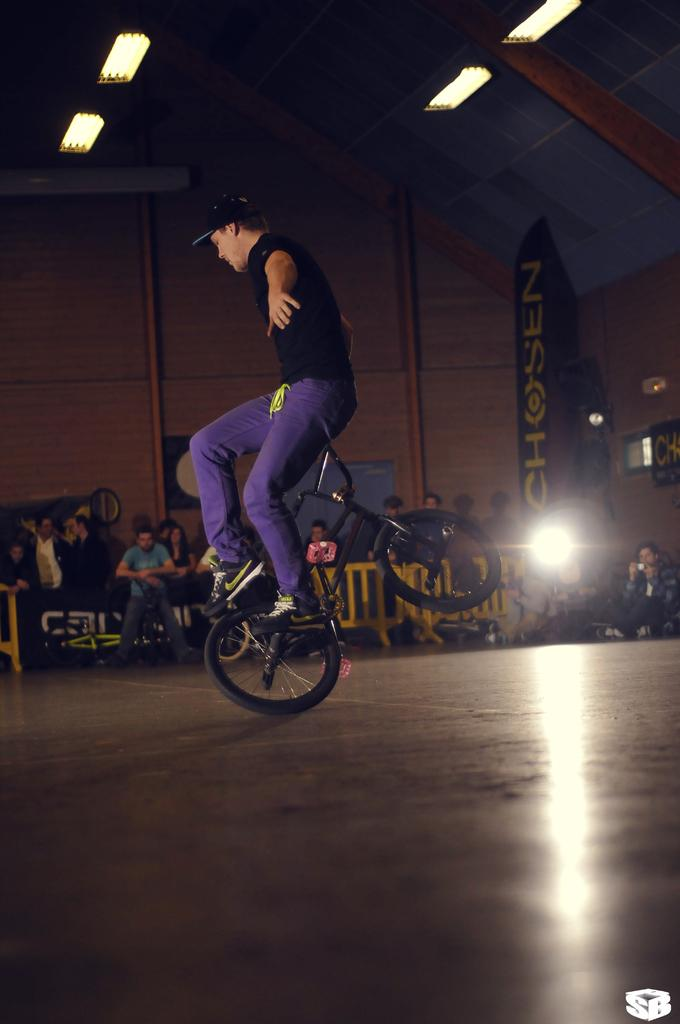How many people are in the image? There are people in the image, but the exact number is not specified. What can be seen in the image besides people? There are lights, railing, banners, a floor, and a bicycle in the image. What is the person sitting on the bicycle handle doing? One person is sitting on the bicycle handle, but their specific action is not described. What type of surface is the floor made of? The type of surface the floor is made of is not specified in the facts. Can you tell me how many ministers are present in the image? There is no mention of ministers in the image, so it is not possible to determine their presence or number. What type of park is visible in the image? There is no park present in the image; it features people, lights, railing, banners, a floor, and a bicycle. 